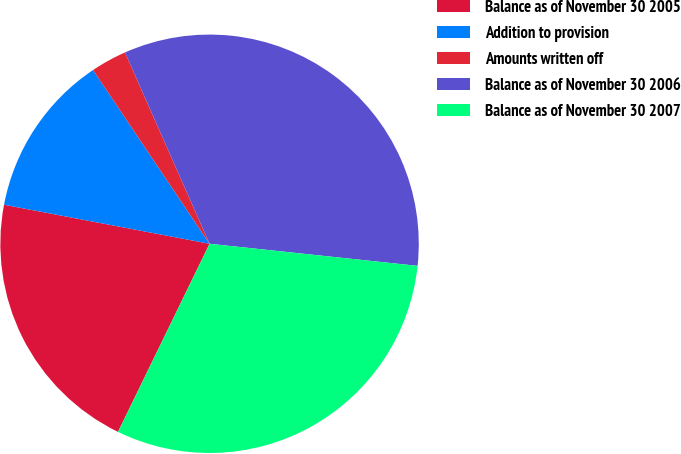Convert chart. <chart><loc_0><loc_0><loc_500><loc_500><pie_chart><fcel>Balance as of November 30 2005<fcel>Addition to provision<fcel>Amounts written off<fcel>Balance as of November 30 2006<fcel>Balance as of November 30 2007<nl><fcel>20.78%<fcel>12.61%<fcel>2.78%<fcel>33.31%<fcel>30.53%<nl></chart> 